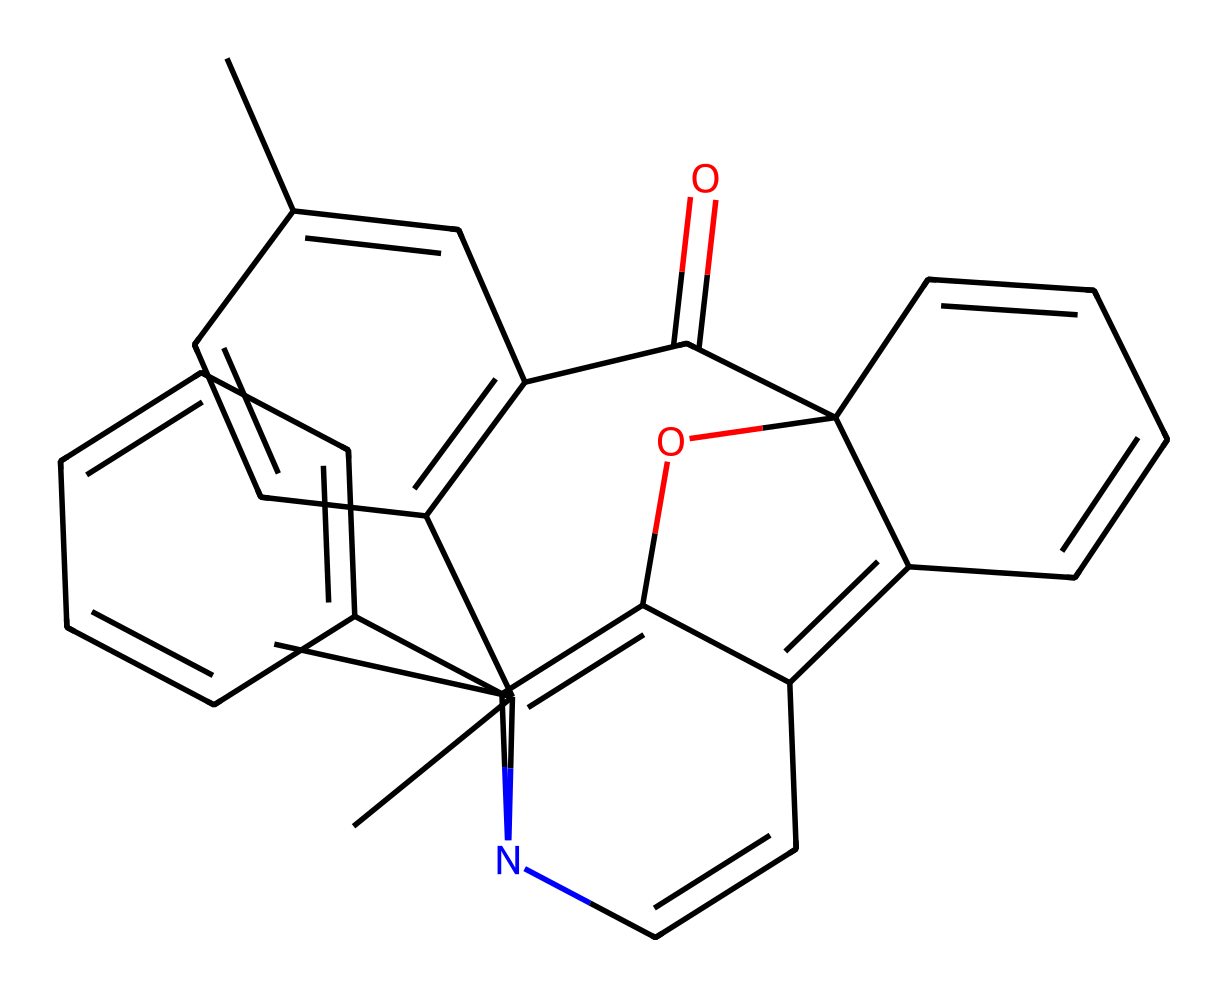What is the total number of carbon atoms in the chemical structure? To find the number of carbon atoms, count the occurrences of 'C' in the SMILES representation. In this case, there are 21 carbon atoms.
Answer: 21 How many rings are present in this chemical structure? By analyzing the structure, we observe multiple cyclic formations, indicating that there are 5 distinct rings in the compound.
Answer: 5 What type of functional groups are present in this spiropyran compound? The compound prominently features an ether group indicated by the 'OC' segment, which suggests it contains an oxygen atom bonded to a carbon in a way that characterizes ethers.
Answer: ether What is the central structure connecting the different parts of the spiropyran compound? The core of the spiropyran structure typically includes a pyran ring, which can be deduced by analyzing the heterocyclic nature of the compound (which includes both carbon and oxygen).
Answer: pyran How many nitrogen atoms can be found in this chemical? In the SMILES representation, count the nitrogen atoms, which are denoted as 'N'. There are 1 nitrogen atom in this chemical structure.
Answer: 1 What role do photoreactive spiropyran compounds play in smart windows? Photoreactive spiropyran compounds change their structural configuration in response to light stimuli, allowing them to have applications in dynamic color changing for smart windows.
Answer: light modulation Which structural feature allows spiropyrans to respond to light? The photoisomerization between their closed and open forms due to the arrangement of double bonds in the structure enables response to light, particularly the presence of the double bonds in their rings.
Answer: double bonds 